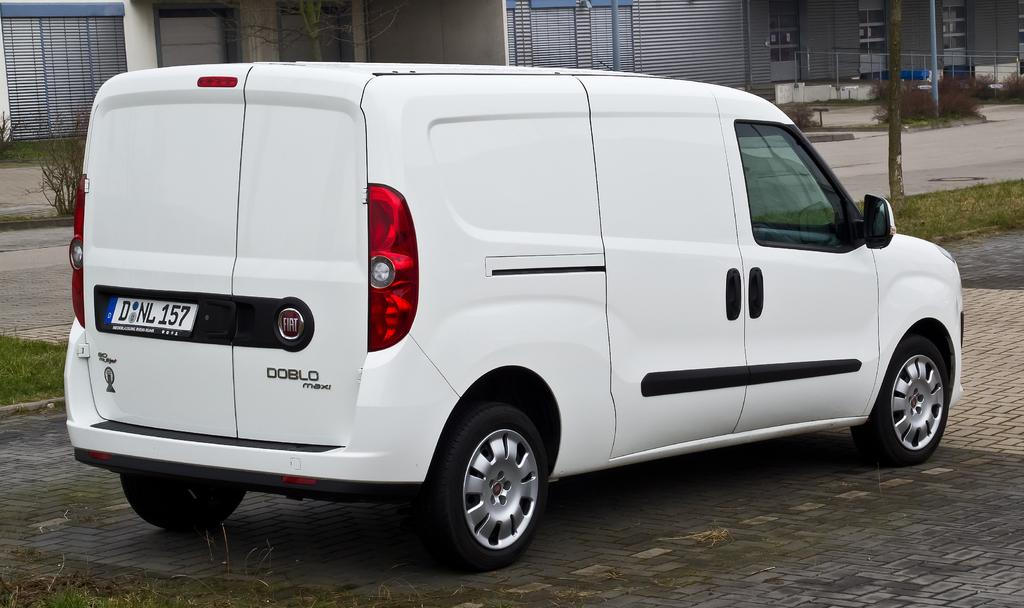<image>
Describe the image concisely. A white van is parked outside and is called Doblo Maxi. 